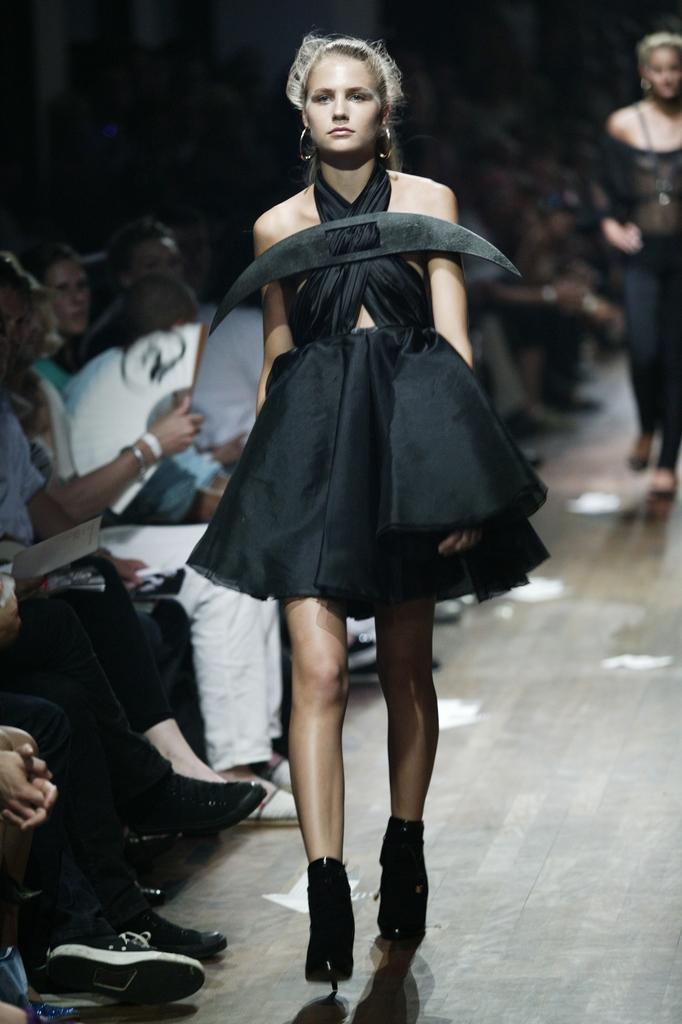Could you give a brief overview of what you see in this image? In the image there is a woman walking on the ramp, it is a fashion show and beside the woman many people were sitting and watching the show, the background of the woman is blur. 